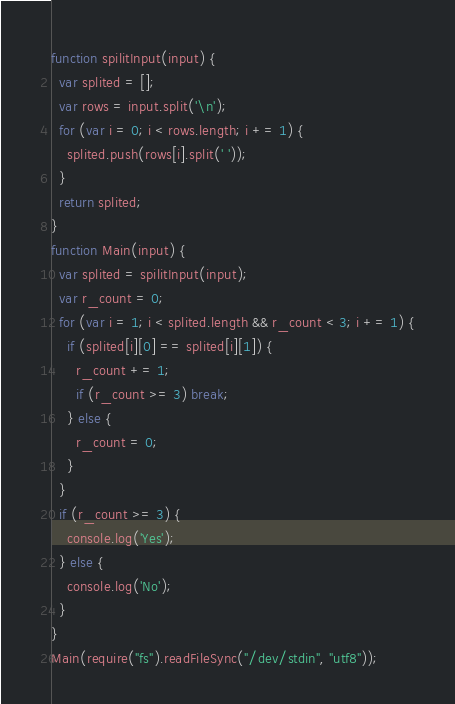<code> <loc_0><loc_0><loc_500><loc_500><_JavaScript_>function spilitInput(input) {
  var splited = [];
  var rows = input.split('\n');
  for (var i = 0; i < rows.length; i += 1) {
    splited.push(rows[i].split(' '));
  }
  return splited;
}
function Main(input) {
  var splited = spilitInput(input);
  var r_count = 0;
  for (var i = 1; i < splited.length && r_count < 3; i += 1) {
    if (splited[i][0] == splited[i][1]) {
      r_count += 1;
      if (r_count >= 3) break;
    } else {
      r_count = 0;
    }
  }
  if (r_count >= 3) {
    console.log('Yes');
  } else {
    console.log('No');
  }
}
Main(require("fs").readFileSync("/dev/stdin", "utf8"));</code> 